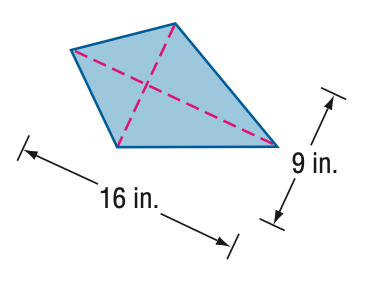Question: Find the area of the kite.
Choices:
A. 72
B. 80
C. 88
D. 96
Answer with the letter. Answer: A 